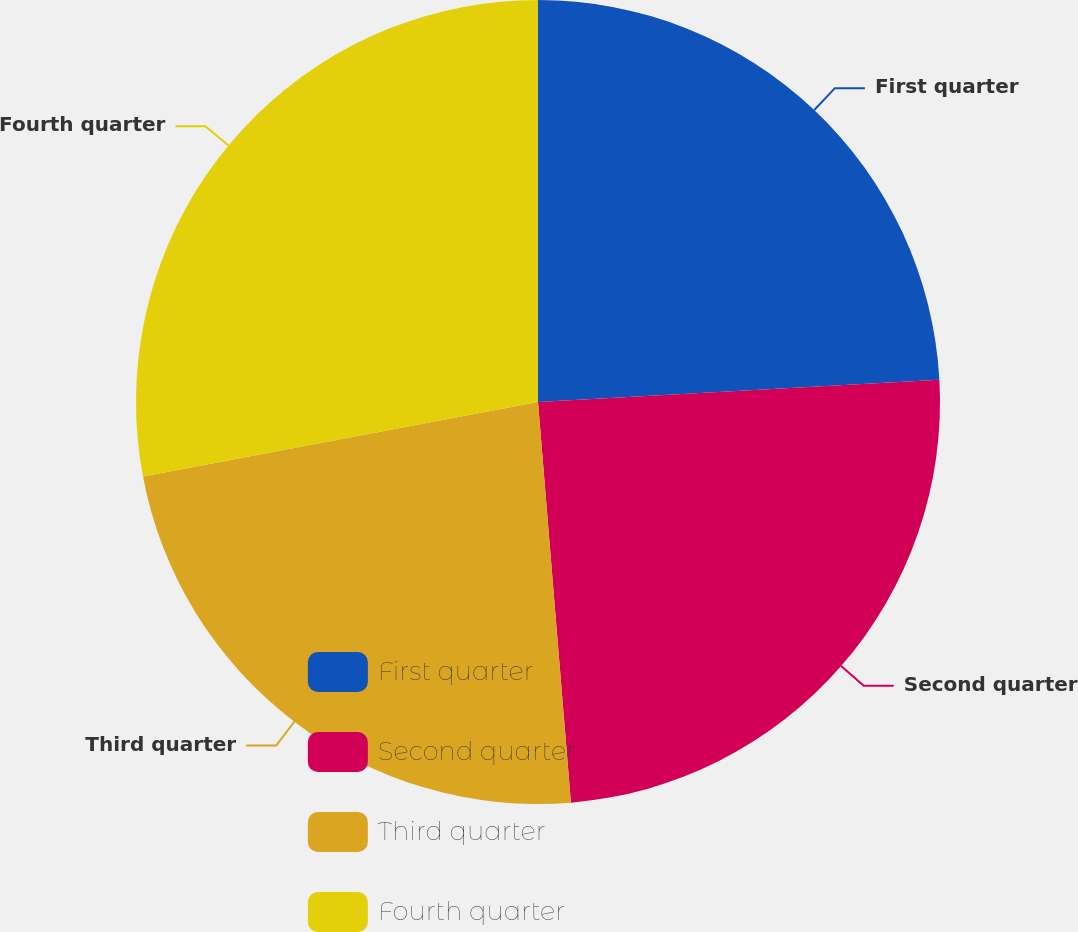<chart> <loc_0><loc_0><loc_500><loc_500><pie_chart><fcel>First quarter<fcel>Second quarter<fcel>Third quarter<fcel>Fourth quarter<nl><fcel>24.12%<fcel>24.58%<fcel>23.34%<fcel>27.97%<nl></chart> 